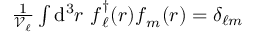<formula> <loc_0><loc_0><loc_500><loc_500>\begin{array} { r } { \frac { 1 } { \mathcal { V } _ { \ell } } \int d ^ { 3 } r f _ { \ell } ^ { \dagger } ( r ) f _ { m } ( r ) = \delta _ { \ell m } } \end{array}</formula> 